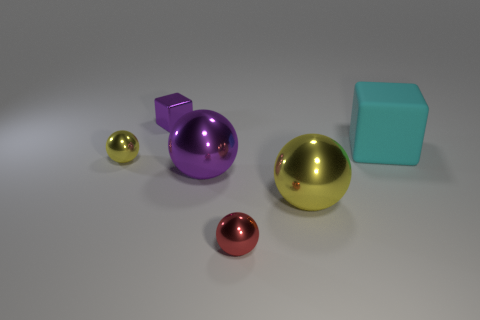Add 4 small red things. How many objects exist? 10 Subtract 1 balls. How many balls are left? 3 Subtract all big purple balls. How many balls are left? 3 Subtract all purple balls. How many balls are left? 3 Subtract all green balls. Subtract all purple cubes. How many balls are left? 4 Subtract all blue cylinders. How many green cubes are left? 0 Subtract all small gray metal cylinders. Subtract all yellow things. How many objects are left? 4 Add 1 purple cubes. How many purple cubes are left? 2 Add 2 large yellow metallic things. How many large yellow metallic things exist? 3 Subtract 0 blue blocks. How many objects are left? 6 